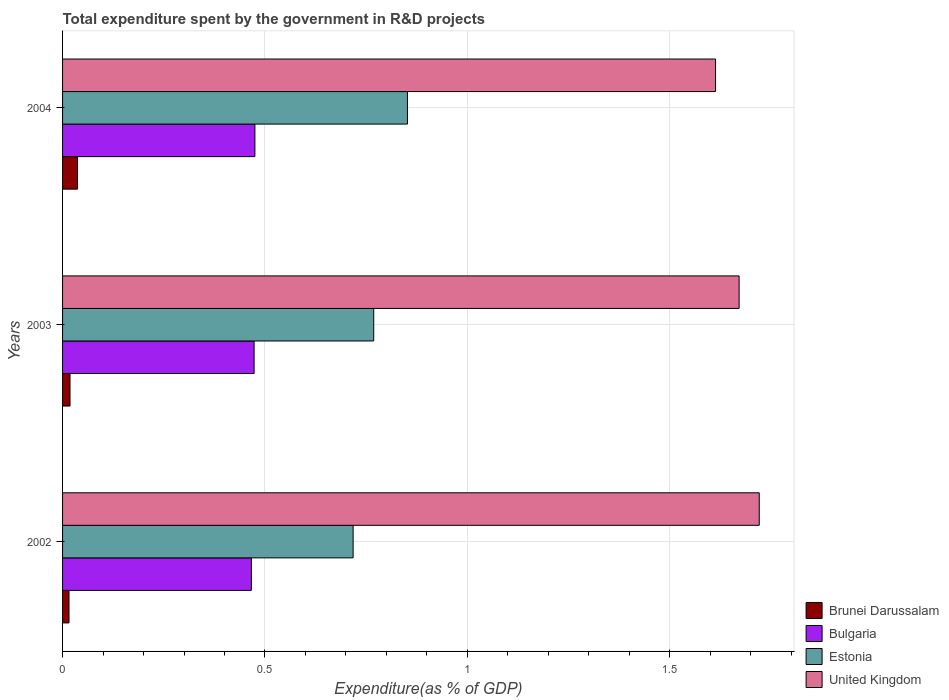Are the number of bars per tick equal to the number of legend labels?
Make the answer very short. Yes. How many bars are there on the 3rd tick from the top?
Your answer should be very brief. 4. What is the label of the 2nd group of bars from the top?
Ensure brevity in your answer.  2003. In how many cases, is the number of bars for a given year not equal to the number of legend labels?
Ensure brevity in your answer.  0. What is the total expenditure spent by the government in R&D projects in Bulgaria in 2003?
Provide a succinct answer. 0.47. Across all years, what is the maximum total expenditure spent by the government in R&D projects in Brunei Darussalam?
Offer a terse response. 0.04. Across all years, what is the minimum total expenditure spent by the government in R&D projects in Estonia?
Give a very brief answer. 0.72. What is the total total expenditure spent by the government in R&D projects in Estonia in the graph?
Provide a short and direct response. 2.34. What is the difference between the total expenditure spent by the government in R&D projects in Brunei Darussalam in 2002 and that in 2004?
Your answer should be very brief. -0.02. What is the difference between the total expenditure spent by the government in R&D projects in Bulgaria in 2003 and the total expenditure spent by the government in R&D projects in Estonia in 2002?
Your response must be concise. -0.24. What is the average total expenditure spent by the government in R&D projects in United Kingdom per year?
Ensure brevity in your answer.  1.67. In the year 2003, what is the difference between the total expenditure spent by the government in R&D projects in Bulgaria and total expenditure spent by the government in R&D projects in Brunei Darussalam?
Offer a terse response. 0.45. In how many years, is the total expenditure spent by the government in R&D projects in Estonia greater than 1.1 %?
Make the answer very short. 0. What is the ratio of the total expenditure spent by the government in R&D projects in United Kingdom in 2002 to that in 2003?
Provide a short and direct response. 1.03. Is the difference between the total expenditure spent by the government in R&D projects in Bulgaria in 2002 and 2004 greater than the difference between the total expenditure spent by the government in R&D projects in Brunei Darussalam in 2002 and 2004?
Keep it short and to the point. Yes. What is the difference between the highest and the second highest total expenditure spent by the government in R&D projects in Estonia?
Your answer should be compact. 0.08. What is the difference between the highest and the lowest total expenditure spent by the government in R&D projects in Bulgaria?
Keep it short and to the point. 0.01. In how many years, is the total expenditure spent by the government in R&D projects in Brunei Darussalam greater than the average total expenditure spent by the government in R&D projects in Brunei Darussalam taken over all years?
Offer a terse response. 1. Is the sum of the total expenditure spent by the government in R&D projects in Bulgaria in 2002 and 2003 greater than the maximum total expenditure spent by the government in R&D projects in Estonia across all years?
Provide a succinct answer. Yes. What does the 2nd bar from the top in 2003 represents?
Give a very brief answer. Estonia. What does the 2nd bar from the bottom in 2003 represents?
Your answer should be very brief. Bulgaria. How many bars are there?
Your answer should be very brief. 12. Are all the bars in the graph horizontal?
Keep it short and to the point. Yes. How many years are there in the graph?
Give a very brief answer. 3. Are the values on the major ticks of X-axis written in scientific E-notation?
Provide a short and direct response. No. Does the graph contain any zero values?
Provide a succinct answer. No. Where does the legend appear in the graph?
Provide a short and direct response. Bottom right. How many legend labels are there?
Offer a terse response. 4. How are the legend labels stacked?
Keep it short and to the point. Vertical. What is the title of the graph?
Give a very brief answer. Total expenditure spent by the government in R&D projects. Does "Andorra" appear as one of the legend labels in the graph?
Give a very brief answer. No. What is the label or title of the X-axis?
Offer a very short reply. Expenditure(as % of GDP). What is the label or title of the Y-axis?
Your answer should be very brief. Years. What is the Expenditure(as % of GDP) in Brunei Darussalam in 2002?
Give a very brief answer. 0.02. What is the Expenditure(as % of GDP) of Bulgaria in 2002?
Keep it short and to the point. 0.47. What is the Expenditure(as % of GDP) of Estonia in 2002?
Keep it short and to the point. 0.72. What is the Expenditure(as % of GDP) in United Kingdom in 2002?
Offer a terse response. 1.72. What is the Expenditure(as % of GDP) in Brunei Darussalam in 2003?
Make the answer very short. 0.02. What is the Expenditure(as % of GDP) in Bulgaria in 2003?
Provide a short and direct response. 0.47. What is the Expenditure(as % of GDP) of Estonia in 2003?
Your answer should be compact. 0.77. What is the Expenditure(as % of GDP) in United Kingdom in 2003?
Your answer should be very brief. 1.67. What is the Expenditure(as % of GDP) of Brunei Darussalam in 2004?
Offer a very short reply. 0.04. What is the Expenditure(as % of GDP) in Bulgaria in 2004?
Give a very brief answer. 0.48. What is the Expenditure(as % of GDP) in Estonia in 2004?
Provide a succinct answer. 0.85. What is the Expenditure(as % of GDP) of United Kingdom in 2004?
Make the answer very short. 1.61. Across all years, what is the maximum Expenditure(as % of GDP) of Brunei Darussalam?
Offer a very short reply. 0.04. Across all years, what is the maximum Expenditure(as % of GDP) in Bulgaria?
Keep it short and to the point. 0.48. Across all years, what is the maximum Expenditure(as % of GDP) of Estonia?
Keep it short and to the point. 0.85. Across all years, what is the maximum Expenditure(as % of GDP) of United Kingdom?
Provide a succinct answer. 1.72. Across all years, what is the minimum Expenditure(as % of GDP) of Brunei Darussalam?
Your response must be concise. 0.02. Across all years, what is the minimum Expenditure(as % of GDP) in Bulgaria?
Offer a terse response. 0.47. Across all years, what is the minimum Expenditure(as % of GDP) in Estonia?
Offer a very short reply. 0.72. Across all years, what is the minimum Expenditure(as % of GDP) in United Kingdom?
Provide a succinct answer. 1.61. What is the total Expenditure(as % of GDP) of Brunei Darussalam in the graph?
Make the answer very short. 0.07. What is the total Expenditure(as % of GDP) of Bulgaria in the graph?
Offer a terse response. 1.41. What is the total Expenditure(as % of GDP) of Estonia in the graph?
Your answer should be very brief. 2.34. What is the total Expenditure(as % of GDP) of United Kingdom in the graph?
Your answer should be very brief. 5.01. What is the difference between the Expenditure(as % of GDP) in Brunei Darussalam in 2002 and that in 2003?
Offer a terse response. -0. What is the difference between the Expenditure(as % of GDP) of Bulgaria in 2002 and that in 2003?
Your response must be concise. -0.01. What is the difference between the Expenditure(as % of GDP) of Estonia in 2002 and that in 2003?
Offer a very short reply. -0.05. What is the difference between the Expenditure(as % of GDP) of United Kingdom in 2002 and that in 2003?
Your answer should be very brief. 0.05. What is the difference between the Expenditure(as % of GDP) in Brunei Darussalam in 2002 and that in 2004?
Offer a terse response. -0.02. What is the difference between the Expenditure(as % of GDP) in Bulgaria in 2002 and that in 2004?
Ensure brevity in your answer.  -0.01. What is the difference between the Expenditure(as % of GDP) in Estonia in 2002 and that in 2004?
Give a very brief answer. -0.13. What is the difference between the Expenditure(as % of GDP) in United Kingdom in 2002 and that in 2004?
Ensure brevity in your answer.  0.11. What is the difference between the Expenditure(as % of GDP) in Brunei Darussalam in 2003 and that in 2004?
Offer a very short reply. -0.02. What is the difference between the Expenditure(as % of GDP) in Bulgaria in 2003 and that in 2004?
Provide a succinct answer. -0. What is the difference between the Expenditure(as % of GDP) in Estonia in 2003 and that in 2004?
Make the answer very short. -0.08. What is the difference between the Expenditure(as % of GDP) in United Kingdom in 2003 and that in 2004?
Provide a succinct answer. 0.06. What is the difference between the Expenditure(as % of GDP) of Brunei Darussalam in 2002 and the Expenditure(as % of GDP) of Bulgaria in 2003?
Ensure brevity in your answer.  -0.46. What is the difference between the Expenditure(as % of GDP) of Brunei Darussalam in 2002 and the Expenditure(as % of GDP) of Estonia in 2003?
Give a very brief answer. -0.75. What is the difference between the Expenditure(as % of GDP) in Brunei Darussalam in 2002 and the Expenditure(as % of GDP) in United Kingdom in 2003?
Keep it short and to the point. -1.66. What is the difference between the Expenditure(as % of GDP) of Bulgaria in 2002 and the Expenditure(as % of GDP) of Estonia in 2003?
Offer a very short reply. -0.3. What is the difference between the Expenditure(as % of GDP) of Bulgaria in 2002 and the Expenditure(as % of GDP) of United Kingdom in 2003?
Provide a succinct answer. -1.21. What is the difference between the Expenditure(as % of GDP) in Estonia in 2002 and the Expenditure(as % of GDP) in United Kingdom in 2003?
Make the answer very short. -0.95. What is the difference between the Expenditure(as % of GDP) in Brunei Darussalam in 2002 and the Expenditure(as % of GDP) in Bulgaria in 2004?
Provide a short and direct response. -0.46. What is the difference between the Expenditure(as % of GDP) in Brunei Darussalam in 2002 and the Expenditure(as % of GDP) in Estonia in 2004?
Your response must be concise. -0.84. What is the difference between the Expenditure(as % of GDP) in Brunei Darussalam in 2002 and the Expenditure(as % of GDP) in United Kingdom in 2004?
Make the answer very short. -1.6. What is the difference between the Expenditure(as % of GDP) in Bulgaria in 2002 and the Expenditure(as % of GDP) in Estonia in 2004?
Offer a very short reply. -0.39. What is the difference between the Expenditure(as % of GDP) of Bulgaria in 2002 and the Expenditure(as % of GDP) of United Kingdom in 2004?
Your response must be concise. -1.15. What is the difference between the Expenditure(as % of GDP) in Estonia in 2002 and the Expenditure(as % of GDP) in United Kingdom in 2004?
Provide a succinct answer. -0.9. What is the difference between the Expenditure(as % of GDP) in Brunei Darussalam in 2003 and the Expenditure(as % of GDP) in Bulgaria in 2004?
Provide a succinct answer. -0.46. What is the difference between the Expenditure(as % of GDP) of Brunei Darussalam in 2003 and the Expenditure(as % of GDP) of Estonia in 2004?
Provide a short and direct response. -0.83. What is the difference between the Expenditure(as % of GDP) of Brunei Darussalam in 2003 and the Expenditure(as % of GDP) of United Kingdom in 2004?
Your answer should be very brief. -1.59. What is the difference between the Expenditure(as % of GDP) of Bulgaria in 2003 and the Expenditure(as % of GDP) of Estonia in 2004?
Give a very brief answer. -0.38. What is the difference between the Expenditure(as % of GDP) in Bulgaria in 2003 and the Expenditure(as % of GDP) in United Kingdom in 2004?
Provide a short and direct response. -1.14. What is the difference between the Expenditure(as % of GDP) of Estonia in 2003 and the Expenditure(as % of GDP) of United Kingdom in 2004?
Your answer should be compact. -0.84. What is the average Expenditure(as % of GDP) in Brunei Darussalam per year?
Offer a very short reply. 0.02. What is the average Expenditure(as % of GDP) in Bulgaria per year?
Offer a terse response. 0.47. What is the average Expenditure(as % of GDP) in Estonia per year?
Your answer should be compact. 0.78. What is the average Expenditure(as % of GDP) in United Kingdom per year?
Ensure brevity in your answer.  1.67. In the year 2002, what is the difference between the Expenditure(as % of GDP) in Brunei Darussalam and Expenditure(as % of GDP) in Bulgaria?
Make the answer very short. -0.45. In the year 2002, what is the difference between the Expenditure(as % of GDP) of Brunei Darussalam and Expenditure(as % of GDP) of Estonia?
Your answer should be compact. -0.7. In the year 2002, what is the difference between the Expenditure(as % of GDP) of Brunei Darussalam and Expenditure(as % of GDP) of United Kingdom?
Ensure brevity in your answer.  -1.71. In the year 2002, what is the difference between the Expenditure(as % of GDP) in Bulgaria and Expenditure(as % of GDP) in Estonia?
Provide a succinct answer. -0.25. In the year 2002, what is the difference between the Expenditure(as % of GDP) in Bulgaria and Expenditure(as % of GDP) in United Kingdom?
Your answer should be compact. -1.25. In the year 2002, what is the difference between the Expenditure(as % of GDP) of Estonia and Expenditure(as % of GDP) of United Kingdom?
Provide a short and direct response. -1. In the year 2003, what is the difference between the Expenditure(as % of GDP) in Brunei Darussalam and Expenditure(as % of GDP) in Bulgaria?
Your response must be concise. -0.45. In the year 2003, what is the difference between the Expenditure(as % of GDP) of Brunei Darussalam and Expenditure(as % of GDP) of Estonia?
Make the answer very short. -0.75. In the year 2003, what is the difference between the Expenditure(as % of GDP) of Brunei Darussalam and Expenditure(as % of GDP) of United Kingdom?
Your response must be concise. -1.65. In the year 2003, what is the difference between the Expenditure(as % of GDP) of Bulgaria and Expenditure(as % of GDP) of Estonia?
Your answer should be very brief. -0.3. In the year 2003, what is the difference between the Expenditure(as % of GDP) of Bulgaria and Expenditure(as % of GDP) of United Kingdom?
Provide a succinct answer. -1.2. In the year 2003, what is the difference between the Expenditure(as % of GDP) of Estonia and Expenditure(as % of GDP) of United Kingdom?
Keep it short and to the point. -0.9. In the year 2004, what is the difference between the Expenditure(as % of GDP) in Brunei Darussalam and Expenditure(as % of GDP) in Bulgaria?
Give a very brief answer. -0.44. In the year 2004, what is the difference between the Expenditure(as % of GDP) in Brunei Darussalam and Expenditure(as % of GDP) in Estonia?
Offer a terse response. -0.81. In the year 2004, what is the difference between the Expenditure(as % of GDP) in Brunei Darussalam and Expenditure(as % of GDP) in United Kingdom?
Your answer should be compact. -1.58. In the year 2004, what is the difference between the Expenditure(as % of GDP) of Bulgaria and Expenditure(as % of GDP) of Estonia?
Make the answer very short. -0.38. In the year 2004, what is the difference between the Expenditure(as % of GDP) in Bulgaria and Expenditure(as % of GDP) in United Kingdom?
Offer a very short reply. -1.14. In the year 2004, what is the difference between the Expenditure(as % of GDP) in Estonia and Expenditure(as % of GDP) in United Kingdom?
Give a very brief answer. -0.76. What is the ratio of the Expenditure(as % of GDP) of Brunei Darussalam in 2002 to that in 2003?
Your answer should be compact. 0.86. What is the ratio of the Expenditure(as % of GDP) in Bulgaria in 2002 to that in 2003?
Provide a succinct answer. 0.99. What is the ratio of the Expenditure(as % of GDP) in Estonia in 2002 to that in 2003?
Make the answer very short. 0.93. What is the ratio of the Expenditure(as % of GDP) of United Kingdom in 2002 to that in 2003?
Offer a very short reply. 1.03. What is the ratio of the Expenditure(as % of GDP) in Brunei Darussalam in 2002 to that in 2004?
Keep it short and to the point. 0.43. What is the ratio of the Expenditure(as % of GDP) of Bulgaria in 2002 to that in 2004?
Keep it short and to the point. 0.98. What is the ratio of the Expenditure(as % of GDP) of Estonia in 2002 to that in 2004?
Offer a very short reply. 0.84. What is the ratio of the Expenditure(as % of GDP) in United Kingdom in 2002 to that in 2004?
Your response must be concise. 1.07. What is the ratio of the Expenditure(as % of GDP) of Brunei Darussalam in 2003 to that in 2004?
Offer a very short reply. 0.5. What is the ratio of the Expenditure(as % of GDP) in Estonia in 2003 to that in 2004?
Ensure brevity in your answer.  0.9. What is the ratio of the Expenditure(as % of GDP) in United Kingdom in 2003 to that in 2004?
Offer a very short reply. 1.04. What is the difference between the highest and the second highest Expenditure(as % of GDP) of Brunei Darussalam?
Provide a short and direct response. 0.02. What is the difference between the highest and the second highest Expenditure(as % of GDP) of Bulgaria?
Your answer should be very brief. 0. What is the difference between the highest and the second highest Expenditure(as % of GDP) in Estonia?
Provide a succinct answer. 0.08. What is the difference between the highest and the second highest Expenditure(as % of GDP) in United Kingdom?
Your answer should be very brief. 0.05. What is the difference between the highest and the lowest Expenditure(as % of GDP) of Brunei Darussalam?
Your response must be concise. 0.02. What is the difference between the highest and the lowest Expenditure(as % of GDP) in Bulgaria?
Your answer should be compact. 0.01. What is the difference between the highest and the lowest Expenditure(as % of GDP) in Estonia?
Your answer should be compact. 0.13. What is the difference between the highest and the lowest Expenditure(as % of GDP) in United Kingdom?
Provide a succinct answer. 0.11. 